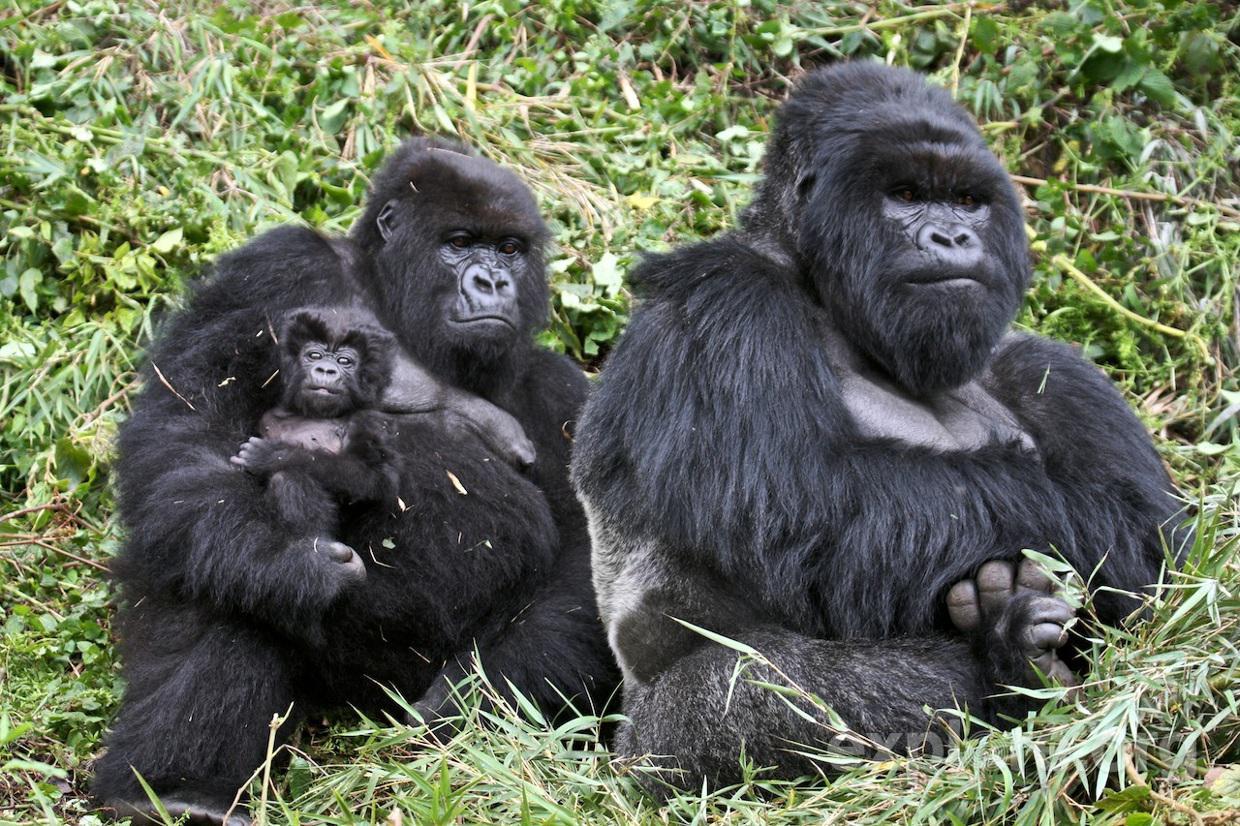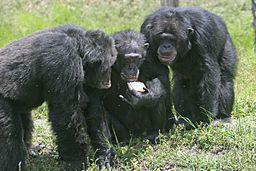The first image is the image on the left, the second image is the image on the right. Given the left and right images, does the statement "One image contains twice as many apes as the other image and includes a baby gorilla." hold true? Answer yes or no. No. The first image is the image on the left, the second image is the image on the right. For the images displayed, is the sentence "There are exactly two gorillas in total." factually correct? Answer yes or no. No. 